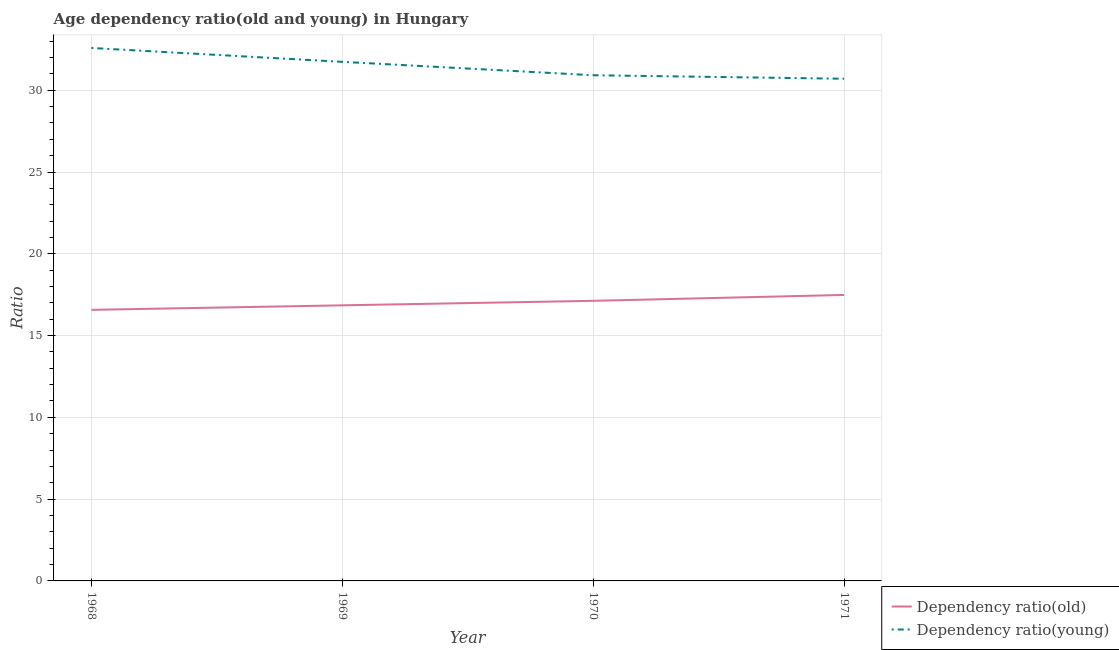How many different coloured lines are there?
Provide a succinct answer. 2. Does the line corresponding to age dependency ratio(young) intersect with the line corresponding to age dependency ratio(old)?
Keep it short and to the point. No. What is the age dependency ratio(old) in 1969?
Your answer should be very brief. 16.85. Across all years, what is the maximum age dependency ratio(young)?
Keep it short and to the point. 32.58. Across all years, what is the minimum age dependency ratio(young)?
Offer a very short reply. 30.7. In which year was the age dependency ratio(old) minimum?
Your answer should be very brief. 1968. What is the total age dependency ratio(old) in the graph?
Provide a short and direct response. 68.03. What is the difference between the age dependency ratio(old) in 1969 and that in 1970?
Provide a short and direct response. -0.28. What is the difference between the age dependency ratio(old) in 1971 and the age dependency ratio(young) in 1970?
Keep it short and to the point. -13.43. What is the average age dependency ratio(old) per year?
Give a very brief answer. 17.01. In the year 1970, what is the difference between the age dependency ratio(young) and age dependency ratio(old)?
Your response must be concise. 13.79. What is the ratio of the age dependency ratio(young) in 1970 to that in 1971?
Give a very brief answer. 1.01. What is the difference between the highest and the second highest age dependency ratio(old)?
Your answer should be very brief. 0.36. What is the difference between the highest and the lowest age dependency ratio(young)?
Your response must be concise. 1.88. In how many years, is the age dependency ratio(old) greater than the average age dependency ratio(old) taken over all years?
Ensure brevity in your answer.  2. Is the sum of the age dependency ratio(young) in 1970 and 1971 greater than the maximum age dependency ratio(old) across all years?
Your answer should be very brief. Yes. How many lines are there?
Ensure brevity in your answer.  2. What is the title of the graph?
Your answer should be very brief. Age dependency ratio(old and young) in Hungary. What is the label or title of the Y-axis?
Your answer should be very brief. Ratio. What is the Ratio in Dependency ratio(old) in 1968?
Make the answer very short. 16.57. What is the Ratio of Dependency ratio(young) in 1968?
Provide a short and direct response. 32.58. What is the Ratio in Dependency ratio(old) in 1969?
Keep it short and to the point. 16.85. What is the Ratio in Dependency ratio(young) in 1969?
Offer a very short reply. 31.74. What is the Ratio in Dependency ratio(old) in 1970?
Your answer should be very brief. 17.12. What is the Ratio in Dependency ratio(young) in 1970?
Give a very brief answer. 30.92. What is the Ratio of Dependency ratio(old) in 1971?
Offer a very short reply. 17.48. What is the Ratio of Dependency ratio(young) in 1971?
Offer a very short reply. 30.7. Across all years, what is the maximum Ratio of Dependency ratio(old)?
Your response must be concise. 17.48. Across all years, what is the maximum Ratio of Dependency ratio(young)?
Provide a succinct answer. 32.58. Across all years, what is the minimum Ratio of Dependency ratio(old)?
Give a very brief answer. 16.57. Across all years, what is the minimum Ratio in Dependency ratio(young)?
Offer a terse response. 30.7. What is the total Ratio of Dependency ratio(old) in the graph?
Make the answer very short. 68.03. What is the total Ratio in Dependency ratio(young) in the graph?
Offer a terse response. 125.94. What is the difference between the Ratio in Dependency ratio(old) in 1968 and that in 1969?
Keep it short and to the point. -0.28. What is the difference between the Ratio in Dependency ratio(young) in 1968 and that in 1969?
Your answer should be very brief. 0.85. What is the difference between the Ratio in Dependency ratio(old) in 1968 and that in 1970?
Provide a short and direct response. -0.55. What is the difference between the Ratio of Dependency ratio(young) in 1968 and that in 1970?
Give a very brief answer. 1.67. What is the difference between the Ratio in Dependency ratio(old) in 1968 and that in 1971?
Ensure brevity in your answer.  -0.91. What is the difference between the Ratio in Dependency ratio(young) in 1968 and that in 1971?
Keep it short and to the point. 1.88. What is the difference between the Ratio in Dependency ratio(old) in 1969 and that in 1970?
Keep it short and to the point. -0.28. What is the difference between the Ratio in Dependency ratio(young) in 1969 and that in 1970?
Keep it short and to the point. 0.82. What is the difference between the Ratio in Dependency ratio(old) in 1969 and that in 1971?
Your answer should be compact. -0.64. What is the difference between the Ratio of Dependency ratio(young) in 1969 and that in 1971?
Your answer should be very brief. 1.03. What is the difference between the Ratio of Dependency ratio(old) in 1970 and that in 1971?
Provide a succinct answer. -0.36. What is the difference between the Ratio of Dependency ratio(young) in 1970 and that in 1971?
Your answer should be very brief. 0.22. What is the difference between the Ratio in Dependency ratio(old) in 1968 and the Ratio in Dependency ratio(young) in 1969?
Keep it short and to the point. -15.16. What is the difference between the Ratio in Dependency ratio(old) in 1968 and the Ratio in Dependency ratio(young) in 1970?
Keep it short and to the point. -14.34. What is the difference between the Ratio in Dependency ratio(old) in 1968 and the Ratio in Dependency ratio(young) in 1971?
Ensure brevity in your answer.  -14.13. What is the difference between the Ratio in Dependency ratio(old) in 1969 and the Ratio in Dependency ratio(young) in 1970?
Make the answer very short. -14.07. What is the difference between the Ratio of Dependency ratio(old) in 1969 and the Ratio of Dependency ratio(young) in 1971?
Ensure brevity in your answer.  -13.85. What is the difference between the Ratio of Dependency ratio(old) in 1970 and the Ratio of Dependency ratio(young) in 1971?
Keep it short and to the point. -13.58. What is the average Ratio of Dependency ratio(old) per year?
Ensure brevity in your answer.  17.01. What is the average Ratio in Dependency ratio(young) per year?
Offer a terse response. 31.48. In the year 1968, what is the difference between the Ratio in Dependency ratio(old) and Ratio in Dependency ratio(young)?
Your response must be concise. -16.01. In the year 1969, what is the difference between the Ratio in Dependency ratio(old) and Ratio in Dependency ratio(young)?
Your response must be concise. -14.89. In the year 1970, what is the difference between the Ratio in Dependency ratio(old) and Ratio in Dependency ratio(young)?
Provide a succinct answer. -13.79. In the year 1971, what is the difference between the Ratio in Dependency ratio(old) and Ratio in Dependency ratio(young)?
Your answer should be compact. -13.22. What is the ratio of the Ratio in Dependency ratio(old) in 1968 to that in 1969?
Your answer should be very brief. 0.98. What is the ratio of the Ratio of Dependency ratio(young) in 1968 to that in 1969?
Your answer should be compact. 1.03. What is the ratio of the Ratio in Dependency ratio(old) in 1968 to that in 1970?
Offer a terse response. 0.97. What is the ratio of the Ratio of Dependency ratio(young) in 1968 to that in 1970?
Ensure brevity in your answer.  1.05. What is the ratio of the Ratio in Dependency ratio(old) in 1968 to that in 1971?
Give a very brief answer. 0.95. What is the ratio of the Ratio of Dependency ratio(young) in 1968 to that in 1971?
Offer a terse response. 1.06. What is the ratio of the Ratio in Dependency ratio(old) in 1969 to that in 1970?
Your answer should be compact. 0.98. What is the ratio of the Ratio in Dependency ratio(young) in 1969 to that in 1970?
Make the answer very short. 1.03. What is the ratio of the Ratio of Dependency ratio(old) in 1969 to that in 1971?
Your answer should be compact. 0.96. What is the ratio of the Ratio of Dependency ratio(young) in 1969 to that in 1971?
Keep it short and to the point. 1.03. What is the ratio of the Ratio of Dependency ratio(old) in 1970 to that in 1971?
Offer a very short reply. 0.98. What is the difference between the highest and the second highest Ratio of Dependency ratio(old)?
Ensure brevity in your answer.  0.36. What is the difference between the highest and the second highest Ratio in Dependency ratio(young)?
Provide a succinct answer. 0.85. What is the difference between the highest and the lowest Ratio in Dependency ratio(old)?
Offer a very short reply. 0.91. What is the difference between the highest and the lowest Ratio in Dependency ratio(young)?
Provide a succinct answer. 1.88. 